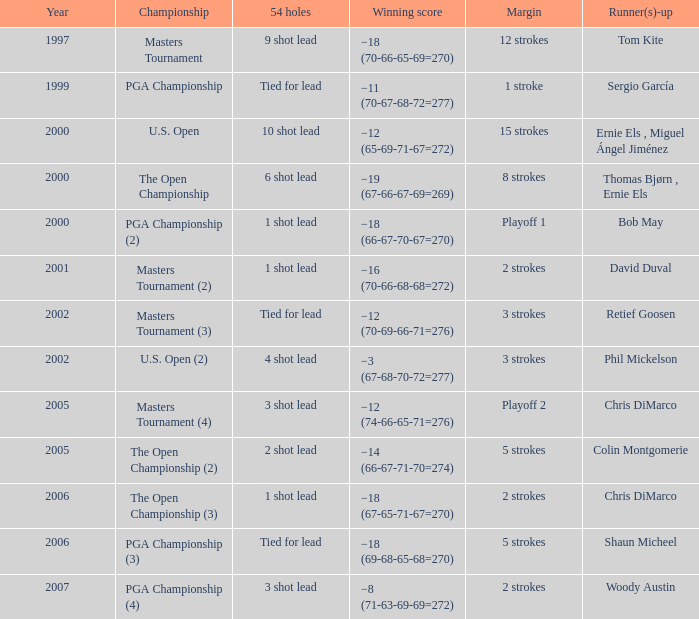 what's the championship where winning score is −12 (74-66-65-71=276) Masters Tournament (4). 